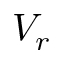<formula> <loc_0><loc_0><loc_500><loc_500>V _ { r }</formula> 